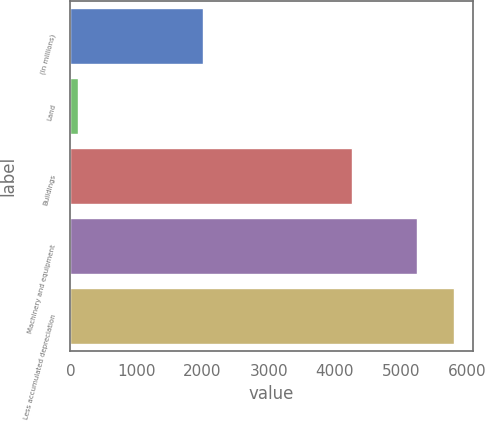<chart> <loc_0><loc_0><loc_500><loc_500><bar_chart><fcel>(In millions)<fcel>Land<fcel>Buildings<fcel>Machinery and equipment<fcel>Less accumulated depreciation<nl><fcel>2006<fcel>121<fcel>4258<fcel>5250<fcel>5795.2<nl></chart> 